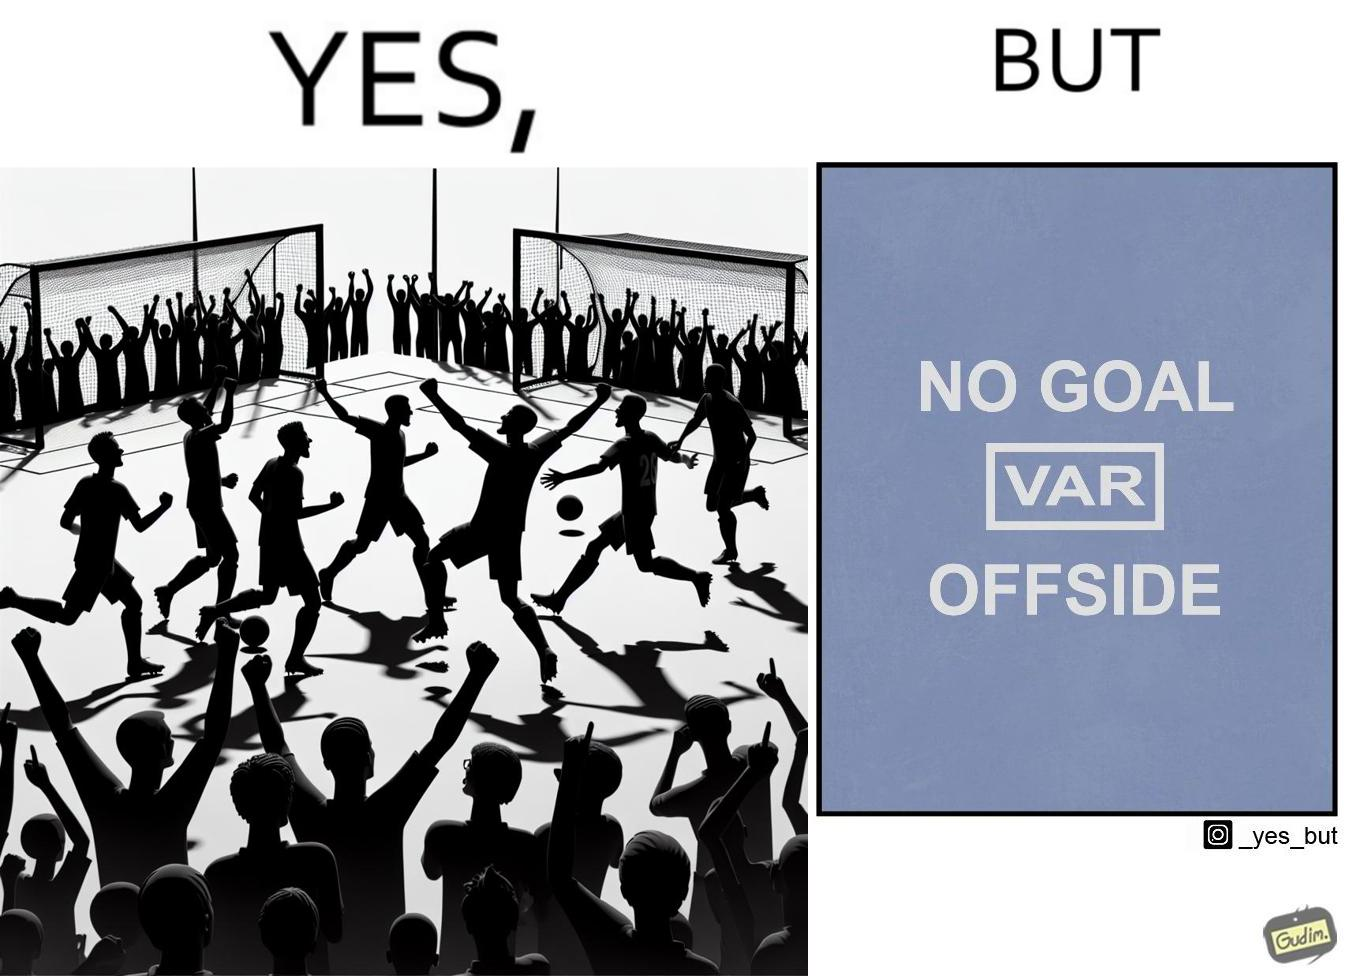Describe the contrast between the left and right parts of this image. In the left part of the image: football players celebrating, probably due a goal their team has scored. In the right part of the image: A sign of "No goal - Offside". 